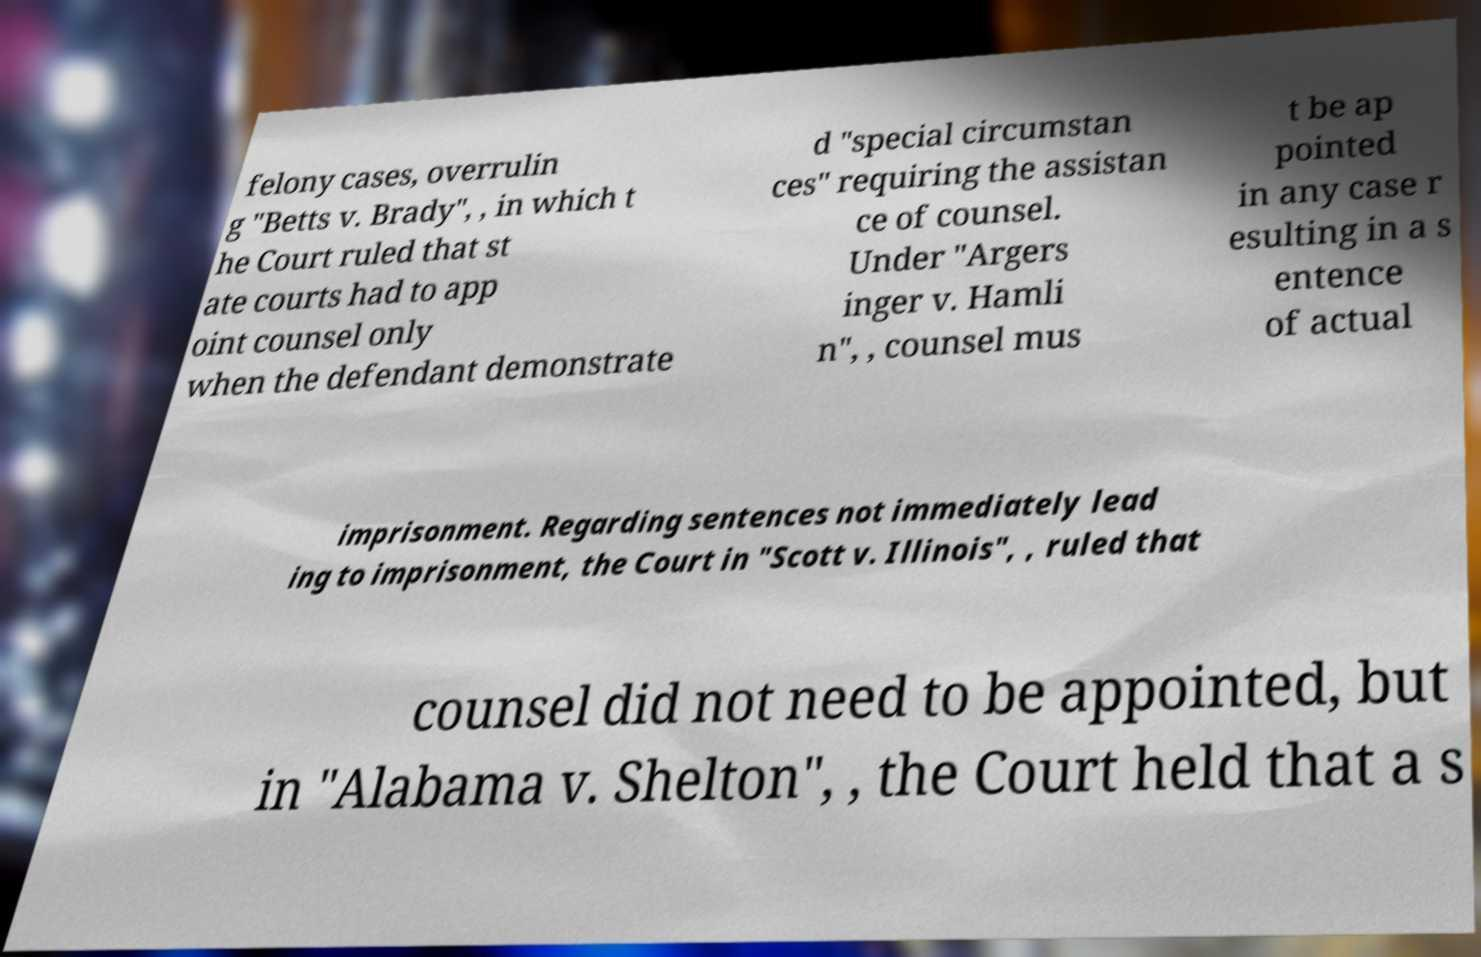Can you read and provide the text displayed in the image?This photo seems to have some interesting text. Can you extract and type it out for me? felony cases, overrulin g "Betts v. Brady", , in which t he Court ruled that st ate courts had to app oint counsel only when the defendant demonstrate d "special circumstan ces" requiring the assistan ce of counsel. Under "Argers inger v. Hamli n", , counsel mus t be ap pointed in any case r esulting in a s entence of actual imprisonment. Regarding sentences not immediately lead ing to imprisonment, the Court in "Scott v. Illinois", , ruled that counsel did not need to be appointed, but in "Alabama v. Shelton", , the Court held that a s 